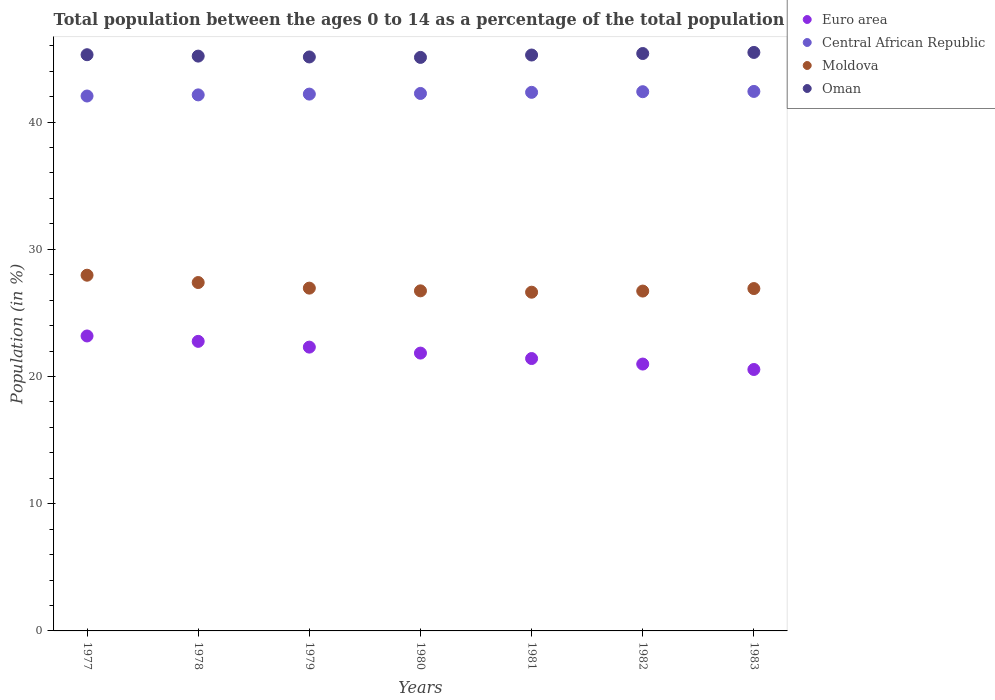Is the number of dotlines equal to the number of legend labels?
Your response must be concise. Yes. What is the percentage of the population ages 0 to 14 in Oman in 1980?
Offer a very short reply. 45.08. Across all years, what is the maximum percentage of the population ages 0 to 14 in Euro area?
Give a very brief answer. 23.18. Across all years, what is the minimum percentage of the population ages 0 to 14 in Central African Republic?
Make the answer very short. 42.04. In which year was the percentage of the population ages 0 to 14 in Euro area maximum?
Your answer should be compact. 1977. In which year was the percentage of the population ages 0 to 14 in Central African Republic minimum?
Your answer should be very brief. 1977. What is the total percentage of the population ages 0 to 14 in Euro area in the graph?
Offer a terse response. 153.02. What is the difference between the percentage of the population ages 0 to 14 in Euro area in 1978 and that in 1981?
Your answer should be compact. 1.35. What is the difference between the percentage of the population ages 0 to 14 in Oman in 1979 and the percentage of the population ages 0 to 14 in Central African Republic in 1978?
Provide a succinct answer. 2.98. What is the average percentage of the population ages 0 to 14 in Oman per year?
Offer a very short reply. 45.25. In the year 1979, what is the difference between the percentage of the population ages 0 to 14 in Oman and percentage of the population ages 0 to 14 in Euro area?
Make the answer very short. 22.81. What is the ratio of the percentage of the population ages 0 to 14 in Euro area in 1977 to that in 1979?
Provide a succinct answer. 1.04. Is the percentage of the population ages 0 to 14 in Oman in 1981 less than that in 1983?
Offer a very short reply. Yes. Is the difference between the percentage of the population ages 0 to 14 in Oman in 1977 and 1983 greater than the difference between the percentage of the population ages 0 to 14 in Euro area in 1977 and 1983?
Offer a very short reply. No. What is the difference between the highest and the second highest percentage of the population ages 0 to 14 in Euro area?
Provide a succinct answer. 0.42. What is the difference between the highest and the lowest percentage of the population ages 0 to 14 in Central African Republic?
Your response must be concise. 0.36. In how many years, is the percentage of the population ages 0 to 14 in Central African Republic greater than the average percentage of the population ages 0 to 14 in Central African Republic taken over all years?
Your response must be concise. 3. Is the sum of the percentage of the population ages 0 to 14 in Oman in 1978 and 1980 greater than the maximum percentage of the population ages 0 to 14 in Central African Republic across all years?
Make the answer very short. Yes. Is it the case that in every year, the sum of the percentage of the population ages 0 to 14 in Central African Republic and percentage of the population ages 0 to 14 in Oman  is greater than the percentage of the population ages 0 to 14 in Euro area?
Give a very brief answer. Yes. Does the percentage of the population ages 0 to 14 in Moldova monotonically increase over the years?
Offer a terse response. No. How many years are there in the graph?
Keep it short and to the point. 7. Where does the legend appear in the graph?
Offer a terse response. Top right. How many legend labels are there?
Provide a succinct answer. 4. How are the legend labels stacked?
Provide a short and direct response. Vertical. What is the title of the graph?
Offer a terse response. Total population between the ages 0 to 14 as a percentage of the total population. What is the label or title of the X-axis?
Provide a short and direct response. Years. What is the label or title of the Y-axis?
Provide a short and direct response. Population (in %). What is the Population (in %) in Euro area in 1977?
Your answer should be very brief. 23.18. What is the Population (in %) of Central African Republic in 1977?
Provide a succinct answer. 42.04. What is the Population (in %) of Moldova in 1977?
Give a very brief answer. 27.96. What is the Population (in %) of Oman in 1977?
Give a very brief answer. 45.29. What is the Population (in %) of Euro area in 1978?
Offer a terse response. 22.76. What is the Population (in %) in Central African Republic in 1978?
Ensure brevity in your answer.  42.13. What is the Population (in %) of Moldova in 1978?
Make the answer very short. 27.38. What is the Population (in %) in Oman in 1978?
Offer a very short reply. 45.18. What is the Population (in %) in Euro area in 1979?
Your response must be concise. 22.31. What is the Population (in %) in Central African Republic in 1979?
Keep it short and to the point. 42.19. What is the Population (in %) of Moldova in 1979?
Make the answer very short. 26.94. What is the Population (in %) of Oman in 1979?
Make the answer very short. 45.11. What is the Population (in %) in Euro area in 1980?
Give a very brief answer. 21.84. What is the Population (in %) in Central African Republic in 1980?
Keep it short and to the point. 42.25. What is the Population (in %) of Moldova in 1980?
Give a very brief answer. 26.73. What is the Population (in %) in Oman in 1980?
Your answer should be very brief. 45.08. What is the Population (in %) of Euro area in 1981?
Provide a short and direct response. 21.41. What is the Population (in %) of Central African Republic in 1981?
Provide a short and direct response. 42.33. What is the Population (in %) in Moldova in 1981?
Ensure brevity in your answer.  26.62. What is the Population (in %) in Oman in 1981?
Give a very brief answer. 45.27. What is the Population (in %) of Euro area in 1982?
Offer a very short reply. 20.98. What is the Population (in %) in Central African Republic in 1982?
Give a very brief answer. 42.38. What is the Population (in %) of Moldova in 1982?
Keep it short and to the point. 26.71. What is the Population (in %) in Oman in 1982?
Ensure brevity in your answer.  45.38. What is the Population (in %) in Euro area in 1983?
Provide a succinct answer. 20.55. What is the Population (in %) of Central African Republic in 1983?
Provide a short and direct response. 42.4. What is the Population (in %) in Moldova in 1983?
Provide a succinct answer. 26.91. What is the Population (in %) of Oman in 1983?
Your answer should be very brief. 45.47. Across all years, what is the maximum Population (in %) of Euro area?
Offer a terse response. 23.18. Across all years, what is the maximum Population (in %) of Central African Republic?
Offer a very short reply. 42.4. Across all years, what is the maximum Population (in %) in Moldova?
Give a very brief answer. 27.96. Across all years, what is the maximum Population (in %) in Oman?
Your response must be concise. 45.47. Across all years, what is the minimum Population (in %) in Euro area?
Your answer should be very brief. 20.55. Across all years, what is the minimum Population (in %) of Central African Republic?
Make the answer very short. 42.04. Across all years, what is the minimum Population (in %) in Moldova?
Ensure brevity in your answer.  26.62. Across all years, what is the minimum Population (in %) in Oman?
Offer a terse response. 45.08. What is the total Population (in %) of Euro area in the graph?
Offer a very short reply. 153.02. What is the total Population (in %) in Central African Republic in the graph?
Give a very brief answer. 295.74. What is the total Population (in %) in Moldova in the graph?
Provide a succinct answer. 189.26. What is the total Population (in %) of Oman in the graph?
Your answer should be very brief. 316.78. What is the difference between the Population (in %) in Euro area in 1977 and that in 1978?
Your answer should be compact. 0.42. What is the difference between the Population (in %) in Central African Republic in 1977 and that in 1978?
Make the answer very short. -0.09. What is the difference between the Population (in %) in Moldova in 1977 and that in 1978?
Ensure brevity in your answer.  0.58. What is the difference between the Population (in %) in Oman in 1977 and that in 1978?
Keep it short and to the point. 0.11. What is the difference between the Population (in %) in Euro area in 1977 and that in 1979?
Your response must be concise. 0.88. What is the difference between the Population (in %) of Central African Republic in 1977 and that in 1979?
Provide a succinct answer. -0.15. What is the difference between the Population (in %) of Moldova in 1977 and that in 1979?
Your answer should be very brief. 1.02. What is the difference between the Population (in %) in Oman in 1977 and that in 1979?
Offer a terse response. 0.18. What is the difference between the Population (in %) of Euro area in 1977 and that in 1980?
Your answer should be very brief. 1.35. What is the difference between the Population (in %) of Central African Republic in 1977 and that in 1980?
Make the answer very short. -0.2. What is the difference between the Population (in %) of Moldova in 1977 and that in 1980?
Offer a very short reply. 1.23. What is the difference between the Population (in %) of Oman in 1977 and that in 1980?
Give a very brief answer. 0.21. What is the difference between the Population (in %) in Euro area in 1977 and that in 1981?
Make the answer very short. 1.77. What is the difference between the Population (in %) in Central African Republic in 1977 and that in 1981?
Provide a succinct answer. -0.29. What is the difference between the Population (in %) in Moldova in 1977 and that in 1981?
Your response must be concise. 1.34. What is the difference between the Population (in %) in Oman in 1977 and that in 1981?
Ensure brevity in your answer.  0.02. What is the difference between the Population (in %) of Euro area in 1977 and that in 1982?
Offer a terse response. 2.21. What is the difference between the Population (in %) in Central African Republic in 1977 and that in 1982?
Provide a short and direct response. -0.34. What is the difference between the Population (in %) in Moldova in 1977 and that in 1982?
Your response must be concise. 1.25. What is the difference between the Population (in %) in Oman in 1977 and that in 1982?
Provide a short and direct response. -0.09. What is the difference between the Population (in %) of Euro area in 1977 and that in 1983?
Ensure brevity in your answer.  2.63. What is the difference between the Population (in %) in Central African Republic in 1977 and that in 1983?
Your answer should be compact. -0.36. What is the difference between the Population (in %) of Moldova in 1977 and that in 1983?
Provide a succinct answer. 1.05. What is the difference between the Population (in %) of Oman in 1977 and that in 1983?
Your answer should be very brief. -0.18. What is the difference between the Population (in %) of Euro area in 1978 and that in 1979?
Keep it short and to the point. 0.45. What is the difference between the Population (in %) in Central African Republic in 1978 and that in 1979?
Keep it short and to the point. -0.06. What is the difference between the Population (in %) in Moldova in 1978 and that in 1979?
Your response must be concise. 0.44. What is the difference between the Population (in %) in Oman in 1978 and that in 1979?
Your response must be concise. 0.07. What is the difference between the Population (in %) of Euro area in 1978 and that in 1980?
Offer a terse response. 0.92. What is the difference between the Population (in %) of Central African Republic in 1978 and that in 1980?
Ensure brevity in your answer.  -0.11. What is the difference between the Population (in %) of Moldova in 1978 and that in 1980?
Give a very brief answer. 0.65. What is the difference between the Population (in %) in Oman in 1978 and that in 1980?
Provide a short and direct response. 0.1. What is the difference between the Population (in %) of Euro area in 1978 and that in 1981?
Provide a succinct answer. 1.35. What is the difference between the Population (in %) of Central African Republic in 1978 and that in 1981?
Keep it short and to the point. -0.2. What is the difference between the Population (in %) in Moldova in 1978 and that in 1981?
Offer a very short reply. 0.76. What is the difference between the Population (in %) in Oman in 1978 and that in 1981?
Make the answer very short. -0.09. What is the difference between the Population (in %) of Euro area in 1978 and that in 1982?
Give a very brief answer. 1.78. What is the difference between the Population (in %) of Central African Republic in 1978 and that in 1982?
Keep it short and to the point. -0.25. What is the difference between the Population (in %) of Moldova in 1978 and that in 1982?
Your answer should be very brief. 0.67. What is the difference between the Population (in %) in Oman in 1978 and that in 1982?
Make the answer very short. -0.2. What is the difference between the Population (in %) of Euro area in 1978 and that in 1983?
Provide a short and direct response. 2.21. What is the difference between the Population (in %) in Central African Republic in 1978 and that in 1983?
Keep it short and to the point. -0.27. What is the difference between the Population (in %) of Moldova in 1978 and that in 1983?
Your answer should be compact. 0.47. What is the difference between the Population (in %) in Oman in 1978 and that in 1983?
Your answer should be compact. -0.29. What is the difference between the Population (in %) in Euro area in 1979 and that in 1980?
Your response must be concise. 0.47. What is the difference between the Population (in %) in Central African Republic in 1979 and that in 1980?
Provide a short and direct response. -0.05. What is the difference between the Population (in %) of Moldova in 1979 and that in 1980?
Make the answer very short. 0.21. What is the difference between the Population (in %) in Oman in 1979 and that in 1980?
Your answer should be very brief. 0.03. What is the difference between the Population (in %) in Euro area in 1979 and that in 1981?
Your answer should be compact. 0.9. What is the difference between the Population (in %) of Central African Republic in 1979 and that in 1981?
Offer a terse response. -0.14. What is the difference between the Population (in %) of Moldova in 1979 and that in 1981?
Keep it short and to the point. 0.32. What is the difference between the Population (in %) of Oman in 1979 and that in 1981?
Provide a short and direct response. -0.15. What is the difference between the Population (in %) in Euro area in 1979 and that in 1982?
Give a very brief answer. 1.33. What is the difference between the Population (in %) of Central African Republic in 1979 and that in 1982?
Offer a terse response. -0.19. What is the difference between the Population (in %) of Moldova in 1979 and that in 1982?
Your answer should be very brief. 0.23. What is the difference between the Population (in %) in Oman in 1979 and that in 1982?
Offer a terse response. -0.27. What is the difference between the Population (in %) of Euro area in 1979 and that in 1983?
Ensure brevity in your answer.  1.76. What is the difference between the Population (in %) of Central African Republic in 1979 and that in 1983?
Give a very brief answer. -0.21. What is the difference between the Population (in %) in Moldova in 1979 and that in 1983?
Give a very brief answer. 0.03. What is the difference between the Population (in %) in Oman in 1979 and that in 1983?
Provide a short and direct response. -0.36. What is the difference between the Population (in %) in Euro area in 1980 and that in 1981?
Your answer should be compact. 0.43. What is the difference between the Population (in %) of Central African Republic in 1980 and that in 1981?
Your answer should be compact. -0.09. What is the difference between the Population (in %) in Moldova in 1980 and that in 1981?
Provide a succinct answer. 0.11. What is the difference between the Population (in %) of Oman in 1980 and that in 1981?
Provide a short and direct response. -0.19. What is the difference between the Population (in %) of Euro area in 1980 and that in 1982?
Ensure brevity in your answer.  0.86. What is the difference between the Population (in %) in Central African Republic in 1980 and that in 1982?
Offer a terse response. -0.14. What is the difference between the Population (in %) of Moldova in 1980 and that in 1982?
Provide a short and direct response. 0.02. What is the difference between the Population (in %) of Oman in 1980 and that in 1982?
Keep it short and to the point. -0.31. What is the difference between the Population (in %) in Euro area in 1980 and that in 1983?
Your answer should be compact. 1.29. What is the difference between the Population (in %) of Central African Republic in 1980 and that in 1983?
Offer a very short reply. -0.16. What is the difference between the Population (in %) in Moldova in 1980 and that in 1983?
Offer a terse response. -0.18. What is the difference between the Population (in %) in Oman in 1980 and that in 1983?
Provide a succinct answer. -0.39. What is the difference between the Population (in %) in Euro area in 1981 and that in 1982?
Make the answer very short. 0.43. What is the difference between the Population (in %) of Central African Republic in 1981 and that in 1982?
Your response must be concise. -0.05. What is the difference between the Population (in %) in Moldova in 1981 and that in 1982?
Your response must be concise. -0.09. What is the difference between the Population (in %) of Oman in 1981 and that in 1982?
Give a very brief answer. -0.12. What is the difference between the Population (in %) of Euro area in 1981 and that in 1983?
Make the answer very short. 0.86. What is the difference between the Population (in %) of Central African Republic in 1981 and that in 1983?
Ensure brevity in your answer.  -0.07. What is the difference between the Population (in %) of Moldova in 1981 and that in 1983?
Your response must be concise. -0.29. What is the difference between the Population (in %) of Oman in 1981 and that in 1983?
Ensure brevity in your answer.  -0.2. What is the difference between the Population (in %) of Euro area in 1982 and that in 1983?
Give a very brief answer. 0.43. What is the difference between the Population (in %) in Central African Republic in 1982 and that in 1983?
Ensure brevity in your answer.  -0.02. What is the difference between the Population (in %) of Moldova in 1982 and that in 1983?
Offer a very short reply. -0.2. What is the difference between the Population (in %) of Oman in 1982 and that in 1983?
Your response must be concise. -0.09. What is the difference between the Population (in %) of Euro area in 1977 and the Population (in %) of Central African Republic in 1978?
Your answer should be very brief. -18.95. What is the difference between the Population (in %) of Euro area in 1977 and the Population (in %) of Moldova in 1978?
Provide a succinct answer. -4.2. What is the difference between the Population (in %) of Euro area in 1977 and the Population (in %) of Oman in 1978?
Make the answer very short. -22. What is the difference between the Population (in %) of Central African Republic in 1977 and the Population (in %) of Moldova in 1978?
Make the answer very short. 14.66. What is the difference between the Population (in %) of Central African Republic in 1977 and the Population (in %) of Oman in 1978?
Your answer should be very brief. -3.14. What is the difference between the Population (in %) of Moldova in 1977 and the Population (in %) of Oman in 1978?
Offer a terse response. -17.22. What is the difference between the Population (in %) in Euro area in 1977 and the Population (in %) in Central African Republic in 1979?
Provide a succinct answer. -19.01. What is the difference between the Population (in %) in Euro area in 1977 and the Population (in %) in Moldova in 1979?
Make the answer very short. -3.76. What is the difference between the Population (in %) of Euro area in 1977 and the Population (in %) of Oman in 1979?
Your answer should be very brief. -21.93. What is the difference between the Population (in %) in Central African Republic in 1977 and the Population (in %) in Moldova in 1979?
Provide a short and direct response. 15.1. What is the difference between the Population (in %) of Central African Republic in 1977 and the Population (in %) of Oman in 1979?
Offer a very short reply. -3.07. What is the difference between the Population (in %) of Moldova in 1977 and the Population (in %) of Oman in 1979?
Offer a terse response. -17.15. What is the difference between the Population (in %) of Euro area in 1977 and the Population (in %) of Central African Republic in 1980?
Keep it short and to the point. -19.06. What is the difference between the Population (in %) of Euro area in 1977 and the Population (in %) of Moldova in 1980?
Provide a succinct answer. -3.55. What is the difference between the Population (in %) in Euro area in 1977 and the Population (in %) in Oman in 1980?
Keep it short and to the point. -21.9. What is the difference between the Population (in %) of Central African Republic in 1977 and the Population (in %) of Moldova in 1980?
Offer a terse response. 15.31. What is the difference between the Population (in %) of Central African Republic in 1977 and the Population (in %) of Oman in 1980?
Your answer should be very brief. -3.04. What is the difference between the Population (in %) in Moldova in 1977 and the Population (in %) in Oman in 1980?
Offer a very short reply. -17.12. What is the difference between the Population (in %) of Euro area in 1977 and the Population (in %) of Central African Republic in 1981?
Give a very brief answer. -19.15. What is the difference between the Population (in %) of Euro area in 1977 and the Population (in %) of Moldova in 1981?
Provide a short and direct response. -3.44. What is the difference between the Population (in %) in Euro area in 1977 and the Population (in %) in Oman in 1981?
Offer a terse response. -22.08. What is the difference between the Population (in %) of Central African Republic in 1977 and the Population (in %) of Moldova in 1981?
Ensure brevity in your answer.  15.42. What is the difference between the Population (in %) in Central African Republic in 1977 and the Population (in %) in Oman in 1981?
Provide a short and direct response. -3.22. What is the difference between the Population (in %) of Moldova in 1977 and the Population (in %) of Oman in 1981?
Give a very brief answer. -17.31. What is the difference between the Population (in %) in Euro area in 1977 and the Population (in %) in Central African Republic in 1982?
Provide a short and direct response. -19.2. What is the difference between the Population (in %) of Euro area in 1977 and the Population (in %) of Moldova in 1982?
Offer a very short reply. -3.53. What is the difference between the Population (in %) in Euro area in 1977 and the Population (in %) in Oman in 1982?
Make the answer very short. -22.2. What is the difference between the Population (in %) of Central African Republic in 1977 and the Population (in %) of Moldova in 1982?
Your response must be concise. 15.33. What is the difference between the Population (in %) in Central African Republic in 1977 and the Population (in %) in Oman in 1982?
Make the answer very short. -3.34. What is the difference between the Population (in %) in Moldova in 1977 and the Population (in %) in Oman in 1982?
Provide a short and direct response. -17.43. What is the difference between the Population (in %) in Euro area in 1977 and the Population (in %) in Central African Republic in 1983?
Make the answer very short. -19.22. What is the difference between the Population (in %) of Euro area in 1977 and the Population (in %) of Moldova in 1983?
Provide a succinct answer. -3.73. What is the difference between the Population (in %) in Euro area in 1977 and the Population (in %) in Oman in 1983?
Provide a succinct answer. -22.29. What is the difference between the Population (in %) of Central African Republic in 1977 and the Population (in %) of Moldova in 1983?
Ensure brevity in your answer.  15.13. What is the difference between the Population (in %) in Central African Republic in 1977 and the Population (in %) in Oman in 1983?
Make the answer very short. -3.43. What is the difference between the Population (in %) of Moldova in 1977 and the Population (in %) of Oman in 1983?
Provide a short and direct response. -17.51. What is the difference between the Population (in %) in Euro area in 1978 and the Population (in %) in Central African Republic in 1979?
Make the answer very short. -19.43. What is the difference between the Population (in %) of Euro area in 1978 and the Population (in %) of Moldova in 1979?
Your response must be concise. -4.18. What is the difference between the Population (in %) in Euro area in 1978 and the Population (in %) in Oman in 1979?
Make the answer very short. -22.35. What is the difference between the Population (in %) in Central African Republic in 1978 and the Population (in %) in Moldova in 1979?
Keep it short and to the point. 15.19. What is the difference between the Population (in %) of Central African Republic in 1978 and the Population (in %) of Oman in 1979?
Your answer should be very brief. -2.98. What is the difference between the Population (in %) in Moldova in 1978 and the Population (in %) in Oman in 1979?
Your answer should be compact. -17.73. What is the difference between the Population (in %) in Euro area in 1978 and the Population (in %) in Central African Republic in 1980?
Provide a succinct answer. -19.49. What is the difference between the Population (in %) in Euro area in 1978 and the Population (in %) in Moldova in 1980?
Offer a very short reply. -3.97. What is the difference between the Population (in %) in Euro area in 1978 and the Population (in %) in Oman in 1980?
Keep it short and to the point. -22.32. What is the difference between the Population (in %) of Central African Republic in 1978 and the Population (in %) of Moldova in 1980?
Make the answer very short. 15.4. What is the difference between the Population (in %) of Central African Republic in 1978 and the Population (in %) of Oman in 1980?
Provide a short and direct response. -2.95. What is the difference between the Population (in %) of Moldova in 1978 and the Population (in %) of Oman in 1980?
Ensure brevity in your answer.  -17.7. What is the difference between the Population (in %) of Euro area in 1978 and the Population (in %) of Central African Republic in 1981?
Make the answer very short. -19.57. What is the difference between the Population (in %) of Euro area in 1978 and the Population (in %) of Moldova in 1981?
Keep it short and to the point. -3.86. What is the difference between the Population (in %) in Euro area in 1978 and the Population (in %) in Oman in 1981?
Offer a terse response. -22.51. What is the difference between the Population (in %) in Central African Republic in 1978 and the Population (in %) in Moldova in 1981?
Offer a very short reply. 15.51. What is the difference between the Population (in %) in Central African Republic in 1978 and the Population (in %) in Oman in 1981?
Provide a succinct answer. -3.13. What is the difference between the Population (in %) of Moldova in 1978 and the Population (in %) of Oman in 1981?
Make the answer very short. -17.88. What is the difference between the Population (in %) of Euro area in 1978 and the Population (in %) of Central African Republic in 1982?
Make the answer very short. -19.62. What is the difference between the Population (in %) of Euro area in 1978 and the Population (in %) of Moldova in 1982?
Ensure brevity in your answer.  -3.95. What is the difference between the Population (in %) in Euro area in 1978 and the Population (in %) in Oman in 1982?
Keep it short and to the point. -22.62. What is the difference between the Population (in %) in Central African Republic in 1978 and the Population (in %) in Moldova in 1982?
Your answer should be compact. 15.42. What is the difference between the Population (in %) of Central African Republic in 1978 and the Population (in %) of Oman in 1982?
Keep it short and to the point. -3.25. What is the difference between the Population (in %) in Moldova in 1978 and the Population (in %) in Oman in 1982?
Provide a succinct answer. -18. What is the difference between the Population (in %) in Euro area in 1978 and the Population (in %) in Central African Republic in 1983?
Provide a short and direct response. -19.64. What is the difference between the Population (in %) in Euro area in 1978 and the Population (in %) in Moldova in 1983?
Offer a very short reply. -4.15. What is the difference between the Population (in %) of Euro area in 1978 and the Population (in %) of Oman in 1983?
Ensure brevity in your answer.  -22.71. What is the difference between the Population (in %) of Central African Republic in 1978 and the Population (in %) of Moldova in 1983?
Your answer should be very brief. 15.22. What is the difference between the Population (in %) in Central African Republic in 1978 and the Population (in %) in Oman in 1983?
Offer a very short reply. -3.34. What is the difference between the Population (in %) of Moldova in 1978 and the Population (in %) of Oman in 1983?
Provide a short and direct response. -18.09. What is the difference between the Population (in %) in Euro area in 1979 and the Population (in %) in Central African Republic in 1980?
Provide a short and direct response. -19.94. What is the difference between the Population (in %) in Euro area in 1979 and the Population (in %) in Moldova in 1980?
Offer a very short reply. -4.42. What is the difference between the Population (in %) of Euro area in 1979 and the Population (in %) of Oman in 1980?
Make the answer very short. -22.77. What is the difference between the Population (in %) in Central African Republic in 1979 and the Population (in %) in Moldova in 1980?
Make the answer very short. 15.46. What is the difference between the Population (in %) in Central African Republic in 1979 and the Population (in %) in Oman in 1980?
Ensure brevity in your answer.  -2.88. What is the difference between the Population (in %) of Moldova in 1979 and the Population (in %) of Oman in 1980?
Keep it short and to the point. -18.14. What is the difference between the Population (in %) in Euro area in 1979 and the Population (in %) in Central African Republic in 1981?
Offer a terse response. -20.03. What is the difference between the Population (in %) of Euro area in 1979 and the Population (in %) of Moldova in 1981?
Provide a succinct answer. -4.32. What is the difference between the Population (in %) in Euro area in 1979 and the Population (in %) in Oman in 1981?
Give a very brief answer. -22.96. What is the difference between the Population (in %) of Central African Republic in 1979 and the Population (in %) of Moldova in 1981?
Provide a short and direct response. 15.57. What is the difference between the Population (in %) of Central African Republic in 1979 and the Population (in %) of Oman in 1981?
Ensure brevity in your answer.  -3.07. What is the difference between the Population (in %) of Moldova in 1979 and the Population (in %) of Oman in 1981?
Keep it short and to the point. -18.32. What is the difference between the Population (in %) of Euro area in 1979 and the Population (in %) of Central African Republic in 1982?
Your response must be concise. -20.08. What is the difference between the Population (in %) in Euro area in 1979 and the Population (in %) in Moldova in 1982?
Your answer should be very brief. -4.41. What is the difference between the Population (in %) in Euro area in 1979 and the Population (in %) in Oman in 1982?
Keep it short and to the point. -23.08. What is the difference between the Population (in %) of Central African Republic in 1979 and the Population (in %) of Moldova in 1982?
Your response must be concise. 15.48. What is the difference between the Population (in %) of Central African Republic in 1979 and the Population (in %) of Oman in 1982?
Make the answer very short. -3.19. What is the difference between the Population (in %) in Moldova in 1979 and the Population (in %) in Oman in 1982?
Offer a very short reply. -18.44. What is the difference between the Population (in %) in Euro area in 1979 and the Population (in %) in Central African Republic in 1983?
Offer a very short reply. -20.1. What is the difference between the Population (in %) in Euro area in 1979 and the Population (in %) in Moldova in 1983?
Make the answer very short. -4.6. What is the difference between the Population (in %) in Euro area in 1979 and the Population (in %) in Oman in 1983?
Offer a terse response. -23.16. What is the difference between the Population (in %) in Central African Republic in 1979 and the Population (in %) in Moldova in 1983?
Your answer should be compact. 15.28. What is the difference between the Population (in %) in Central African Republic in 1979 and the Population (in %) in Oman in 1983?
Provide a succinct answer. -3.28. What is the difference between the Population (in %) in Moldova in 1979 and the Population (in %) in Oman in 1983?
Give a very brief answer. -18.53. What is the difference between the Population (in %) in Euro area in 1980 and the Population (in %) in Central African Republic in 1981?
Keep it short and to the point. -20.5. What is the difference between the Population (in %) in Euro area in 1980 and the Population (in %) in Moldova in 1981?
Make the answer very short. -4.79. What is the difference between the Population (in %) in Euro area in 1980 and the Population (in %) in Oman in 1981?
Provide a short and direct response. -23.43. What is the difference between the Population (in %) in Central African Republic in 1980 and the Population (in %) in Moldova in 1981?
Make the answer very short. 15.62. What is the difference between the Population (in %) in Central African Republic in 1980 and the Population (in %) in Oman in 1981?
Ensure brevity in your answer.  -3.02. What is the difference between the Population (in %) of Moldova in 1980 and the Population (in %) of Oman in 1981?
Provide a succinct answer. -18.54. What is the difference between the Population (in %) in Euro area in 1980 and the Population (in %) in Central African Republic in 1982?
Your response must be concise. -20.55. What is the difference between the Population (in %) in Euro area in 1980 and the Population (in %) in Moldova in 1982?
Keep it short and to the point. -4.88. What is the difference between the Population (in %) of Euro area in 1980 and the Population (in %) of Oman in 1982?
Ensure brevity in your answer.  -23.55. What is the difference between the Population (in %) in Central African Republic in 1980 and the Population (in %) in Moldova in 1982?
Keep it short and to the point. 15.53. What is the difference between the Population (in %) in Central African Republic in 1980 and the Population (in %) in Oman in 1982?
Give a very brief answer. -3.14. What is the difference between the Population (in %) in Moldova in 1980 and the Population (in %) in Oman in 1982?
Ensure brevity in your answer.  -18.65. What is the difference between the Population (in %) of Euro area in 1980 and the Population (in %) of Central African Republic in 1983?
Give a very brief answer. -20.57. What is the difference between the Population (in %) of Euro area in 1980 and the Population (in %) of Moldova in 1983?
Provide a succinct answer. -5.07. What is the difference between the Population (in %) of Euro area in 1980 and the Population (in %) of Oman in 1983?
Provide a succinct answer. -23.63. What is the difference between the Population (in %) of Central African Republic in 1980 and the Population (in %) of Moldova in 1983?
Give a very brief answer. 15.34. What is the difference between the Population (in %) in Central African Republic in 1980 and the Population (in %) in Oman in 1983?
Offer a very short reply. -3.23. What is the difference between the Population (in %) in Moldova in 1980 and the Population (in %) in Oman in 1983?
Keep it short and to the point. -18.74. What is the difference between the Population (in %) in Euro area in 1981 and the Population (in %) in Central African Republic in 1982?
Make the answer very short. -20.97. What is the difference between the Population (in %) in Euro area in 1981 and the Population (in %) in Moldova in 1982?
Give a very brief answer. -5.3. What is the difference between the Population (in %) of Euro area in 1981 and the Population (in %) of Oman in 1982?
Offer a very short reply. -23.98. What is the difference between the Population (in %) in Central African Republic in 1981 and the Population (in %) in Moldova in 1982?
Provide a short and direct response. 15.62. What is the difference between the Population (in %) in Central African Republic in 1981 and the Population (in %) in Oman in 1982?
Provide a succinct answer. -3.05. What is the difference between the Population (in %) in Moldova in 1981 and the Population (in %) in Oman in 1982?
Provide a short and direct response. -18.76. What is the difference between the Population (in %) in Euro area in 1981 and the Population (in %) in Central African Republic in 1983?
Offer a very short reply. -20.99. What is the difference between the Population (in %) in Euro area in 1981 and the Population (in %) in Moldova in 1983?
Offer a very short reply. -5.5. What is the difference between the Population (in %) in Euro area in 1981 and the Population (in %) in Oman in 1983?
Keep it short and to the point. -24.06. What is the difference between the Population (in %) in Central African Republic in 1981 and the Population (in %) in Moldova in 1983?
Your answer should be compact. 15.42. What is the difference between the Population (in %) in Central African Republic in 1981 and the Population (in %) in Oman in 1983?
Your answer should be compact. -3.14. What is the difference between the Population (in %) of Moldova in 1981 and the Population (in %) of Oman in 1983?
Keep it short and to the point. -18.85. What is the difference between the Population (in %) of Euro area in 1982 and the Population (in %) of Central African Republic in 1983?
Make the answer very short. -21.43. What is the difference between the Population (in %) of Euro area in 1982 and the Population (in %) of Moldova in 1983?
Give a very brief answer. -5.93. What is the difference between the Population (in %) of Euro area in 1982 and the Population (in %) of Oman in 1983?
Provide a short and direct response. -24.49. What is the difference between the Population (in %) of Central African Republic in 1982 and the Population (in %) of Moldova in 1983?
Your response must be concise. 15.47. What is the difference between the Population (in %) in Central African Republic in 1982 and the Population (in %) in Oman in 1983?
Your response must be concise. -3.09. What is the difference between the Population (in %) of Moldova in 1982 and the Population (in %) of Oman in 1983?
Provide a succinct answer. -18.76. What is the average Population (in %) of Euro area per year?
Provide a succinct answer. 21.86. What is the average Population (in %) in Central African Republic per year?
Offer a very short reply. 42.25. What is the average Population (in %) of Moldova per year?
Make the answer very short. 27.04. What is the average Population (in %) of Oman per year?
Provide a short and direct response. 45.26. In the year 1977, what is the difference between the Population (in %) in Euro area and Population (in %) in Central African Republic?
Your response must be concise. -18.86. In the year 1977, what is the difference between the Population (in %) of Euro area and Population (in %) of Moldova?
Make the answer very short. -4.78. In the year 1977, what is the difference between the Population (in %) of Euro area and Population (in %) of Oman?
Give a very brief answer. -22.11. In the year 1977, what is the difference between the Population (in %) of Central African Republic and Population (in %) of Moldova?
Your answer should be compact. 14.08. In the year 1977, what is the difference between the Population (in %) of Central African Republic and Population (in %) of Oman?
Give a very brief answer. -3.25. In the year 1977, what is the difference between the Population (in %) in Moldova and Population (in %) in Oman?
Your answer should be very brief. -17.33. In the year 1978, what is the difference between the Population (in %) in Euro area and Population (in %) in Central African Republic?
Provide a succinct answer. -19.37. In the year 1978, what is the difference between the Population (in %) in Euro area and Population (in %) in Moldova?
Your answer should be very brief. -4.62. In the year 1978, what is the difference between the Population (in %) of Euro area and Population (in %) of Oman?
Your response must be concise. -22.42. In the year 1978, what is the difference between the Population (in %) of Central African Republic and Population (in %) of Moldova?
Your answer should be compact. 14.75. In the year 1978, what is the difference between the Population (in %) in Central African Republic and Population (in %) in Oman?
Offer a terse response. -3.05. In the year 1978, what is the difference between the Population (in %) in Moldova and Population (in %) in Oman?
Provide a short and direct response. -17.8. In the year 1979, what is the difference between the Population (in %) in Euro area and Population (in %) in Central African Republic?
Make the answer very short. -19.89. In the year 1979, what is the difference between the Population (in %) in Euro area and Population (in %) in Moldova?
Ensure brevity in your answer.  -4.64. In the year 1979, what is the difference between the Population (in %) of Euro area and Population (in %) of Oman?
Provide a succinct answer. -22.81. In the year 1979, what is the difference between the Population (in %) of Central African Republic and Population (in %) of Moldova?
Make the answer very short. 15.25. In the year 1979, what is the difference between the Population (in %) of Central African Republic and Population (in %) of Oman?
Give a very brief answer. -2.92. In the year 1979, what is the difference between the Population (in %) in Moldova and Population (in %) in Oman?
Your answer should be very brief. -18.17. In the year 1980, what is the difference between the Population (in %) of Euro area and Population (in %) of Central African Republic?
Your answer should be very brief. -20.41. In the year 1980, what is the difference between the Population (in %) of Euro area and Population (in %) of Moldova?
Offer a very short reply. -4.89. In the year 1980, what is the difference between the Population (in %) in Euro area and Population (in %) in Oman?
Your response must be concise. -23.24. In the year 1980, what is the difference between the Population (in %) of Central African Republic and Population (in %) of Moldova?
Offer a terse response. 15.51. In the year 1980, what is the difference between the Population (in %) of Central African Republic and Population (in %) of Oman?
Keep it short and to the point. -2.83. In the year 1980, what is the difference between the Population (in %) in Moldova and Population (in %) in Oman?
Provide a succinct answer. -18.35. In the year 1981, what is the difference between the Population (in %) of Euro area and Population (in %) of Central African Republic?
Offer a very short reply. -20.92. In the year 1981, what is the difference between the Population (in %) in Euro area and Population (in %) in Moldova?
Offer a very short reply. -5.21. In the year 1981, what is the difference between the Population (in %) in Euro area and Population (in %) in Oman?
Keep it short and to the point. -23.86. In the year 1981, what is the difference between the Population (in %) in Central African Republic and Population (in %) in Moldova?
Your answer should be compact. 15.71. In the year 1981, what is the difference between the Population (in %) of Central African Republic and Population (in %) of Oman?
Offer a terse response. -2.93. In the year 1981, what is the difference between the Population (in %) in Moldova and Population (in %) in Oman?
Your answer should be very brief. -18.64. In the year 1982, what is the difference between the Population (in %) of Euro area and Population (in %) of Central African Republic?
Your answer should be compact. -21.41. In the year 1982, what is the difference between the Population (in %) in Euro area and Population (in %) in Moldova?
Provide a succinct answer. -5.74. In the year 1982, what is the difference between the Population (in %) of Euro area and Population (in %) of Oman?
Give a very brief answer. -24.41. In the year 1982, what is the difference between the Population (in %) in Central African Republic and Population (in %) in Moldova?
Provide a succinct answer. 15.67. In the year 1982, what is the difference between the Population (in %) of Central African Republic and Population (in %) of Oman?
Your answer should be compact. -3. In the year 1982, what is the difference between the Population (in %) in Moldova and Population (in %) in Oman?
Your answer should be compact. -18.67. In the year 1983, what is the difference between the Population (in %) of Euro area and Population (in %) of Central African Republic?
Provide a succinct answer. -21.86. In the year 1983, what is the difference between the Population (in %) of Euro area and Population (in %) of Moldova?
Make the answer very short. -6.36. In the year 1983, what is the difference between the Population (in %) of Euro area and Population (in %) of Oman?
Ensure brevity in your answer.  -24.92. In the year 1983, what is the difference between the Population (in %) in Central African Republic and Population (in %) in Moldova?
Ensure brevity in your answer.  15.49. In the year 1983, what is the difference between the Population (in %) in Central African Republic and Population (in %) in Oman?
Your answer should be compact. -3.07. In the year 1983, what is the difference between the Population (in %) of Moldova and Population (in %) of Oman?
Your answer should be compact. -18.56. What is the ratio of the Population (in %) of Euro area in 1977 to that in 1978?
Provide a short and direct response. 1.02. What is the ratio of the Population (in %) in Central African Republic in 1977 to that in 1978?
Your response must be concise. 1. What is the ratio of the Population (in %) of Moldova in 1977 to that in 1978?
Keep it short and to the point. 1.02. What is the ratio of the Population (in %) of Oman in 1977 to that in 1978?
Make the answer very short. 1. What is the ratio of the Population (in %) of Euro area in 1977 to that in 1979?
Your response must be concise. 1.04. What is the ratio of the Population (in %) in Moldova in 1977 to that in 1979?
Make the answer very short. 1.04. What is the ratio of the Population (in %) in Euro area in 1977 to that in 1980?
Your answer should be compact. 1.06. What is the ratio of the Population (in %) of Moldova in 1977 to that in 1980?
Your answer should be very brief. 1.05. What is the ratio of the Population (in %) in Oman in 1977 to that in 1980?
Your answer should be compact. 1. What is the ratio of the Population (in %) in Euro area in 1977 to that in 1981?
Keep it short and to the point. 1.08. What is the ratio of the Population (in %) in Central African Republic in 1977 to that in 1981?
Your answer should be very brief. 0.99. What is the ratio of the Population (in %) of Moldova in 1977 to that in 1981?
Give a very brief answer. 1.05. What is the ratio of the Population (in %) of Oman in 1977 to that in 1981?
Your response must be concise. 1. What is the ratio of the Population (in %) of Euro area in 1977 to that in 1982?
Keep it short and to the point. 1.11. What is the ratio of the Population (in %) in Moldova in 1977 to that in 1982?
Give a very brief answer. 1.05. What is the ratio of the Population (in %) of Euro area in 1977 to that in 1983?
Your answer should be compact. 1.13. What is the ratio of the Population (in %) of Central African Republic in 1977 to that in 1983?
Give a very brief answer. 0.99. What is the ratio of the Population (in %) of Moldova in 1977 to that in 1983?
Keep it short and to the point. 1.04. What is the ratio of the Population (in %) in Oman in 1977 to that in 1983?
Provide a succinct answer. 1. What is the ratio of the Population (in %) in Euro area in 1978 to that in 1979?
Ensure brevity in your answer.  1.02. What is the ratio of the Population (in %) of Moldova in 1978 to that in 1979?
Provide a short and direct response. 1.02. What is the ratio of the Population (in %) of Oman in 1978 to that in 1979?
Make the answer very short. 1. What is the ratio of the Population (in %) in Euro area in 1978 to that in 1980?
Your answer should be very brief. 1.04. What is the ratio of the Population (in %) of Central African Republic in 1978 to that in 1980?
Your answer should be very brief. 1. What is the ratio of the Population (in %) in Moldova in 1978 to that in 1980?
Your answer should be very brief. 1.02. What is the ratio of the Population (in %) in Oman in 1978 to that in 1980?
Offer a very short reply. 1. What is the ratio of the Population (in %) in Euro area in 1978 to that in 1981?
Make the answer very short. 1.06. What is the ratio of the Population (in %) of Moldova in 1978 to that in 1981?
Your answer should be very brief. 1.03. What is the ratio of the Population (in %) in Oman in 1978 to that in 1981?
Your answer should be very brief. 1. What is the ratio of the Population (in %) in Euro area in 1978 to that in 1982?
Keep it short and to the point. 1.08. What is the ratio of the Population (in %) in Moldova in 1978 to that in 1982?
Make the answer very short. 1.03. What is the ratio of the Population (in %) of Oman in 1978 to that in 1982?
Make the answer very short. 1. What is the ratio of the Population (in %) of Euro area in 1978 to that in 1983?
Your response must be concise. 1.11. What is the ratio of the Population (in %) of Moldova in 1978 to that in 1983?
Your answer should be very brief. 1.02. What is the ratio of the Population (in %) of Oman in 1978 to that in 1983?
Make the answer very short. 0.99. What is the ratio of the Population (in %) of Euro area in 1979 to that in 1980?
Offer a terse response. 1.02. What is the ratio of the Population (in %) in Central African Republic in 1979 to that in 1980?
Your response must be concise. 1. What is the ratio of the Population (in %) in Oman in 1979 to that in 1980?
Offer a terse response. 1. What is the ratio of the Population (in %) of Euro area in 1979 to that in 1981?
Your response must be concise. 1.04. What is the ratio of the Population (in %) of Central African Republic in 1979 to that in 1981?
Offer a terse response. 1. What is the ratio of the Population (in %) of Moldova in 1979 to that in 1981?
Provide a succinct answer. 1.01. What is the ratio of the Population (in %) in Oman in 1979 to that in 1981?
Make the answer very short. 1. What is the ratio of the Population (in %) in Euro area in 1979 to that in 1982?
Offer a very short reply. 1.06. What is the ratio of the Population (in %) in Central African Republic in 1979 to that in 1982?
Ensure brevity in your answer.  1. What is the ratio of the Population (in %) of Moldova in 1979 to that in 1982?
Your answer should be compact. 1.01. What is the ratio of the Population (in %) of Oman in 1979 to that in 1982?
Provide a short and direct response. 0.99. What is the ratio of the Population (in %) in Euro area in 1979 to that in 1983?
Your response must be concise. 1.09. What is the ratio of the Population (in %) of Moldova in 1979 to that in 1983?
Your answer should be very brief. 1. What is the ratio of the Population (in %) in Euro area in 1980 to that in 1981?
Your response must be concise. 1.02. What is the ratio of the Population (in %) in Central African Republic in 1980 to that in 1981?
Provide a succinct answer. 1. What is the ratio of the Population (in %) in Moldova in 1980 to that in 1981?
Make the answer very short. 1. What is the ratio of the Population (in %) in Oman in 1980 to that in 1981?
Your answer should be compact. 1. What is the ratio of the Population (in %) in Euro area in 1980 to that in 1982?
Keep it short and to the point. 1.04. What is the ratio of the Population (in %) of Euro area in 1980 to that in 1983?
Your answer should be very brief. 1.06. What is the ratio of the Population (in %) of Euro area in 1981 to that in 1982?
Your answer should be very brief. 1.02. What is the ratio of the Population (in %) of Central African Republic in 1981 to that in 1982?
Provide a succinct answer. 1. What is the ratio of the Population (in %) in Oman in 1981 to that in 1982?
Offer a very short reply. 1. What is the ratio of the Population (in %) of Euro area in 1981 to that in 1983?
Keep it short and to the point. 1.04. What is the ratio of the Population (in %) in Central African Republic in 1981 to that in 1983?
Your answer should be very brief. 1. What is the ratio of the Population (in %) of Oman in 1981 to that in 1983?
Your response must be concise. 1. What is the ratio of the Population (in %) in Euro area in 1982 to that in 1983?
Offer a very short reply. 1.02. What is the ratio of the Population (in %) of Central African Republic in 1982 to that in 1983?
Your response must be concise. 1. What is the ratio of the Population (in %) of Oman in 1982 to that in 1983?
Your answer should be compact. 1. What is the difference between the highest and the second highest Population (in %) in Euro area?
Your response must be concise. 0.42. What is the difference between the highest and the second highest Population (in %) in Central African Republic?
Give a very brief answer. 0.02. What is the difference between the highest and the second highest Population (in %) of Moldova?
Offer a very short reply. 0.58. What is the difference between the highest and the second highest Population (in %) of Oman?
Your response must be concise. 0.09. What is the difference between the highest and the lowest Population (in %) in Euro area?
Make the answer very short. 2.63. What is the difference between the highest and the lowest Population (in %) of Central African Republic?
Your answer should be very brief. 0.36. What is the difference between the highest and the lowest Population (in %) of Moldova?
Offer a very short reply. 1.34. What is the difference between the highest and the lowest Population (in %) in Oman?
Keep it short and to the point. 0.39. 